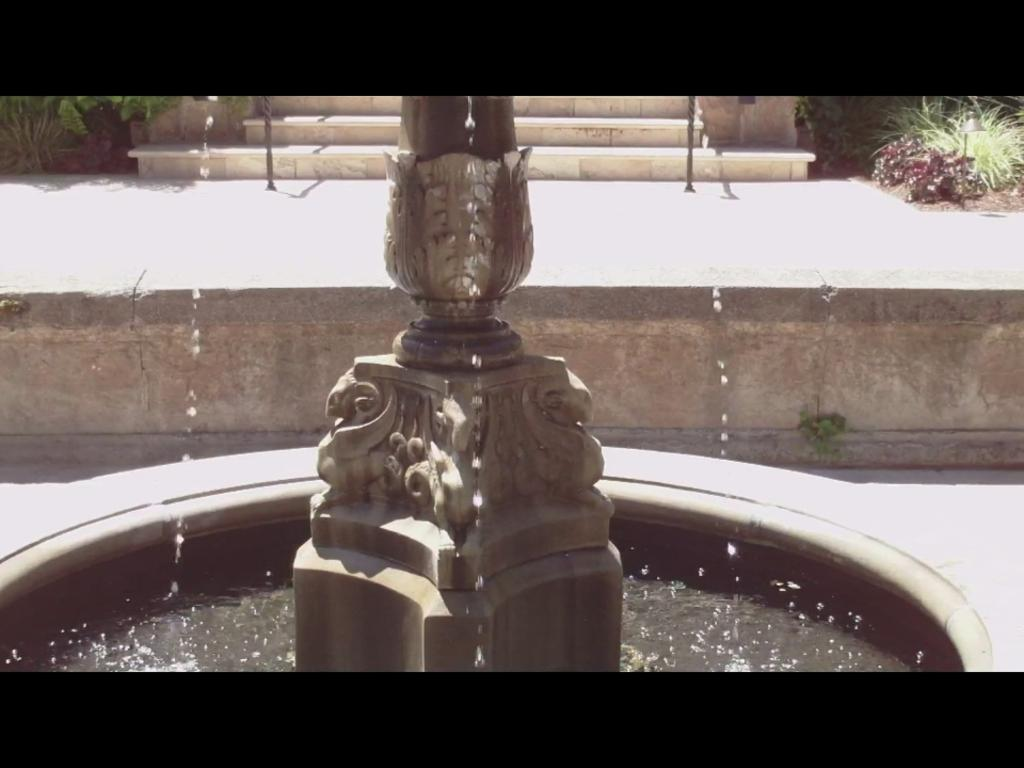What type of architectural feature can be seen in the background of the image? There are stairs in the background of the image. What other elements can be seen in the background of the image? There are plants in the background of the image. What natural element is visible in the image? There is water visible in the image. What object is present in the image? There is a pedestal in the image. What type of discussion is taking place in the image? There is no discussion taking place in the image. Can you see a cannon in the image? There is no cannon present in the image. 